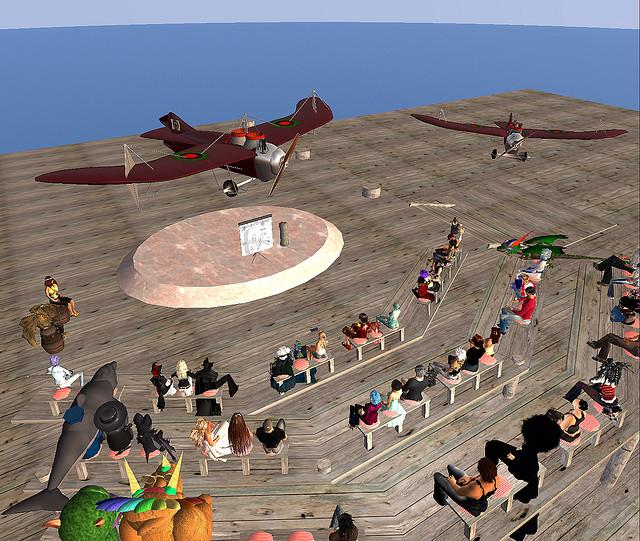What makes this picture look 'not real'?
Write a very short answer. People. Is this a video game?
Quick response, please. Yes. What kind of architecture is this?
Keep it brief. Stadium. Are there planes visible?
Write a very short answer. Yes. 